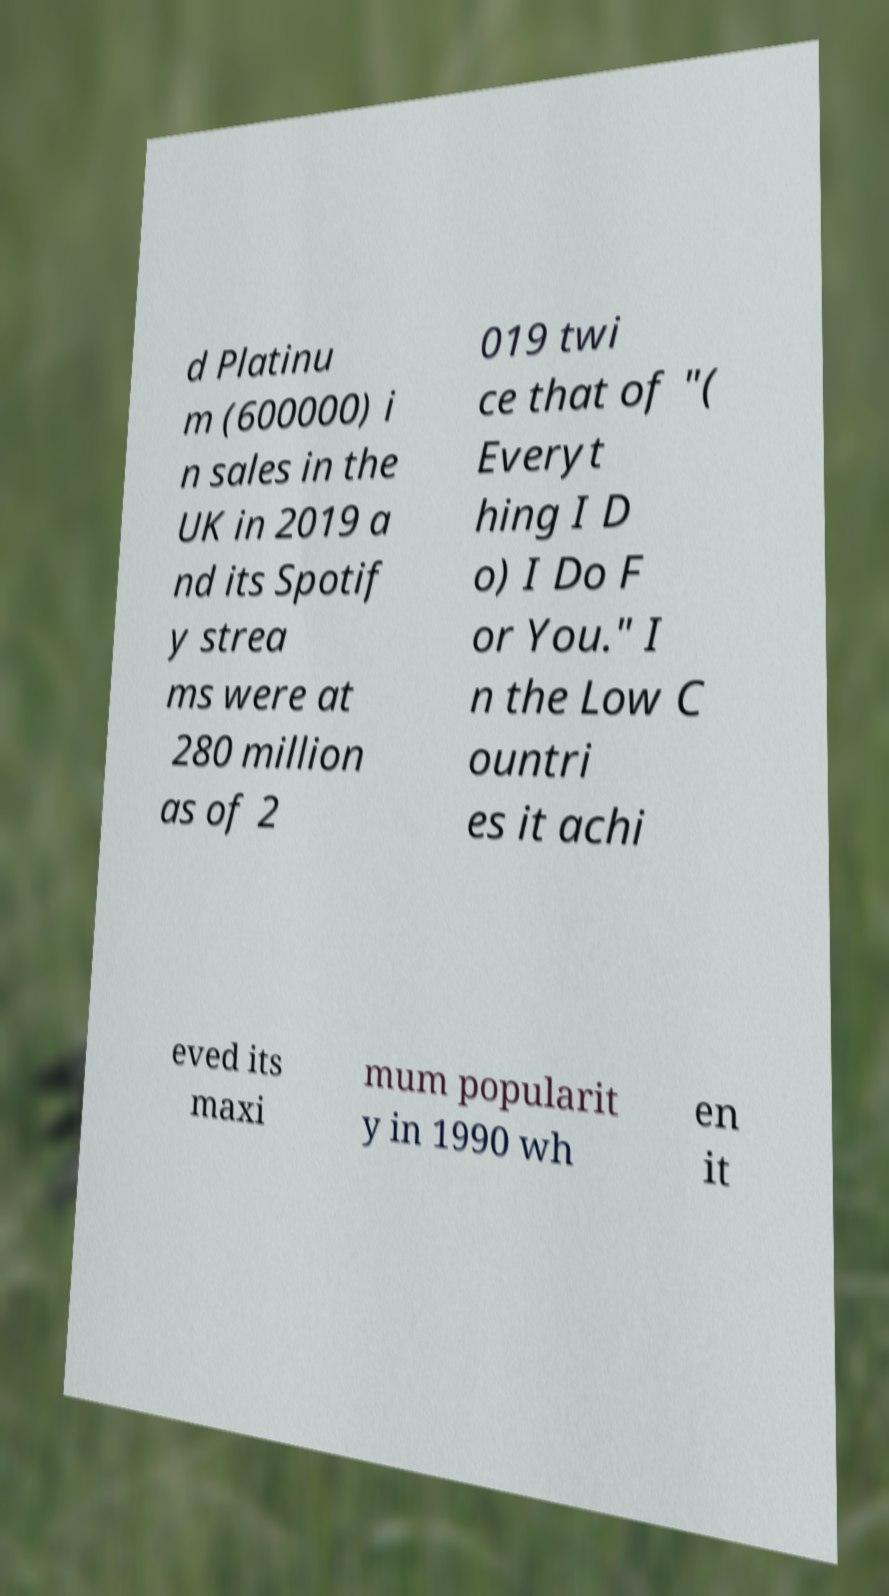Can you read and provide the text displayed in the image?This photo seems to have some interesting text. Can you extract and type it out for me? d Platinu m (600000) i n sales in the UK in 2019 a nd its Spotif y strea ms were at 280 million as of 2 019 twi ce that of "( Everyt hing I D o) I Do F or You." I n the Low C ountri es it achi eved its maxi mum popularit y in 1990 wh en it 